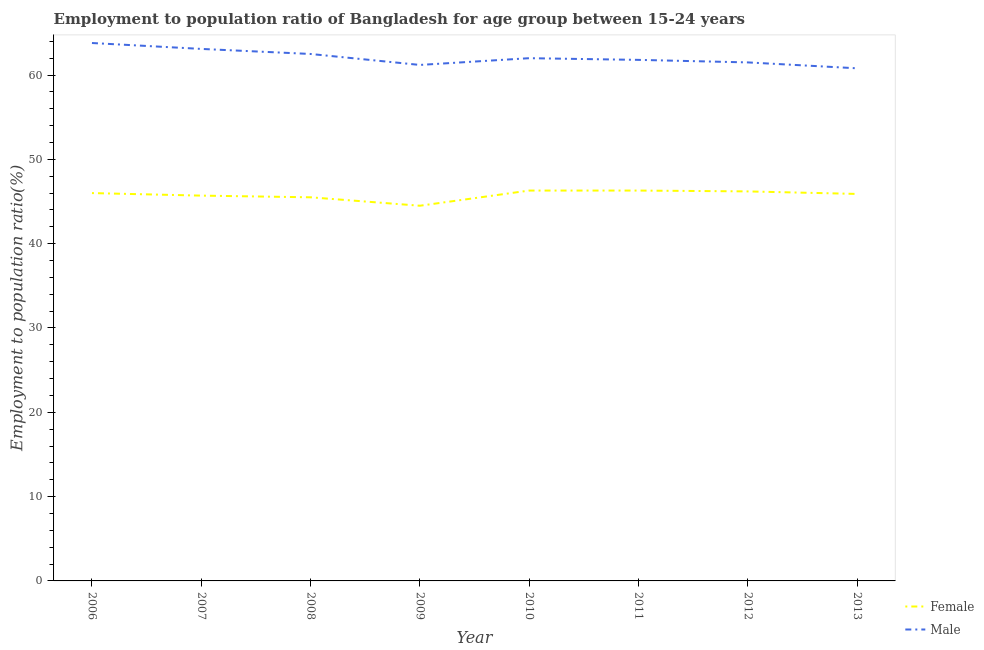How many different coloured lines are there?
Your answer should be very brief. 2. What is the employment to population ratio(male) in 2012?
Your response must be concise. 61.5. Across all years, what is the maximum employment to population ratio(female)?
Your response must be concise. 46.3. Across all years, what is the minimum employment to population ratio(female)?
Offer a terse response. 44.5. In which year was the employment to population ratio(male) minimum?
Offer a terse response. 2013. What is the total employment to population ratio(female) in the graph?
Your answer should be very brief. 366.4. What is the difference between the employment to population ratio(male) in 2008 and that in 2009?
Your answer should be very brief. 1.3. What is the average employment to population ratio(female) per year?
Offer a very short reply. 45.8. In the year 2011, what is the difference between the employment to population ratio(male) and employment to population ratio(female)?
Give a very brief answer. 15.5. In how many years, is the employment to population ratio(female) greater than 28 %?
Ensure brevity in your answer.  8. What is the ratio of the employment to population ratio(male) in 2009 to that in 2011?
Your response must be concise. 0.99. Is the difference between the employment to population ratio(male) in 2008 and 2013 greater than the difference between the employment to population ratio(female) in 2008 and 2013?
Your answer should be compact. Yes. What is the difference between the highest and the second highest employment to population ratio(male)?
Offer a very short reply. 0.7. Is the sum of the employment to population ratio(female) in 2009 and 2010 greater than the maximum employment to population ratio(male) across all years?
Your response must be concise. Yes. Does the employment to population ratio(male) monotonically increase over the years?
Your answer should be compact. No. Is the employment to population ratio(female) strictly less than the employment to population ratio(male) over the years?
Your response must be concise. Yes. How many years are there in the graph?
Your answer should be compact. 8. Are the values on the major ticks of Y-axis written in scientific E-notation?
Your response must be concise. No. Where does the legend appear in the graph?
Provide a short and direct response. Bottom right. How are the legend labels stacked?
Your answer should be very brief. Vertical. What is the title of the graph?
Provide a succinct answer. Employment to population ratio of Bangladesh for age group between 15-24 years. What is the label or title of the Y-axis?
Offer a very short reply. Employment to population ratio(%). What is the Employment to population ratio(%) in Female in 2006?
Provide a short and direct response. 46. What is the Employment to population ratio(%) of Male in 2006?
Keep it short and to the point. 63.8. What is the Employment to population ratio(%) of Female in 2007?
Make the answer very short. 45.7. What is the Employment to population ratio(%) of Male in 2007?
Your response must be concise. 63.1. What is the Employment to population ratio(%) in Female in 2008?
Your response must be concise. 45.5. What is the Employment to population ratio(%) in Male in 2008?
Offer a very short reply. 62.5. What is the Employment to population ratio(%) of Female in 2009?
Ensure brevity in your answer.  44.5. What is the Employment to population ratio(%) in Male in 2009?
Provide a short and direct response. 61.2. What is the Employment to population ratio(%) in Female in 2010?
Offer a terse response. 46.3. What is the Employment to population ratio(%) in Female in 2011?
Your answer should be compact. 46.3. What is the Employment to population ratio(%) in Male in 2011?
Provide a succinct answer. 61.8. What is the Employment to population ratio(%) in Female in 2012?
Provide a succinct answer. 46.2. What is the Employment to population ratio(%) in Male in 2012?
Make the answer very short. 61.5. What is the Employment to population ratio(%) of Female in 2013?
Provide a short and direct response. 45.9. What is the Employment to population ratio(%) of Male in 2013?
Make the answer very short. 60.8. Across all years, what is the maximum Employment to population ratio(%) in Female?
Provide a succinct answer. 46.3. Across all years, what is the maximum Employment to population ratio(%) of Male?
Provide a succinct answer. 63.8. Across all years, what is the minimum Employment to population ratio(%) of Female?
Offer a terse response. 44.5. Across all years, what is the minimum Employment to population ratio(%) in Male?
Keep it short and to the point. 60.8. What is the total Employment to population ratio(%) of Female in the graph?
Give a very brief answer. 366.4. What is the total Employment to population ratio(%) of Male in the graph?
Your response must be concise. 496.7. What is the difference between the Employment to population ratio(%) of Female in 2006 and that in 2007?
Give a very brief answer. 0.3. What is the difference between the Employment to population ratio(%) of Male in 2006 and that in 2008?
Your response must be concise. 1.3. What is the difference between the Employment to population ratio(%) of Female in 2006 and that in 2009?
Your answer should be compact. 1.5. What is the difference between the Employment to population ratio(%) of Male in 2006 and that in 2009?
Ensure brevity in your answer.  2.6. What is the difference between the Employment to population ratio(%) of Male in 2006 and that in 2010?
Ensure brevity in your answer.  1.8. What is the difference between the Employment to population ratio(%) of Female in 2007 and that in 2008?
Offer a terse response. 0.2. What is the difference between the Employment to population ratio(%) of Female in 2007 and that in 2010?
Your answer should be compact. -0.6. What is the difference between the Employment to population ratio(%) of Female in 2007 and that in 2011?
Provide a succinct answer. -0.6. What is the difference between the Employment to population ratio(%) in Male in 2007 and that in 2011?
Your answer should be compact. 1.3. What is the difference between the Employment to population ratio(%) of Female in 2008 and that in 2010?
Your answer should be very brief. -0.8. What is the difference between the Employment to population ratio(%) in Female in 2008 and that in 2012?
Your answer should be compact. -0.7. What is the difference between the Employment to population ratio(%) in Male in 2008 and that in 2012?
Ensure brevity in your answer.  1. What is the difference between the Employment to population ratio(%) of Male in 2008 and that in 2013?
Give a very brief answer. 1.7. What is the difference between the Employment to population ratio(%) in Male in 2009 and that in 2010?
Keep it short and to the point. -0.8. What is the difference between the Employment to population ratio(%) in Female in 2009 and that in 2011?
Keep it short and to the point. -1.8. What is the difference between the Employment to population ratio(%) of Male in 2009 and that in 2011?
Provide a succinct answer. -0.6. What is the difference between the Employment to population ratio(%) in Male in 2009 and that in 2012?
Keep it short and to the point. -0.3. What is the difference between the Employment to population ratio(%) of Male in 2009 and that in 2013?
Ensure brevity in your answer.  0.4. What is the difference between the Employment to population ratio(%) of Male in 2010 and that in 2012?
Provide a short and direct response. 0.5. What is the difference between the Employment to population ratio(%) of Female in 2010 and that in 2013?
Ensure brevity in your answer.  0.4. What is the difference between the Employment to population ratio(%) in Male in 2010 and that in 2013?
Offer a terse response. 1.2. What is the difference between the Employment to population ratio(%) in Female in 2011 and that in 2012?
Your answer should be compact. 0.1. What is the difference between the Employment to population ratio(%) of Male in 2011 and that in 2013?
Your answer should be very brief. 1. What is the difference between the Employment to population ratio(%) of Female in 2012 and that in 2013?
Provide a short and direct response. 0.3. What is the difference between the Employment to population ratio(%) of Female in 2006 and the Employment to population ratio(%) of Male in 2007?
Ensure brevity in your answer.  -17.1. What is the difference between the Employment to population ratio(%) of Female in 2006 and the Employment to population ratio(%) of Male in 2008?
Your answer should be compact. -16.5. What is the difference between the Employment to population ratio(%) in Female in 2006 and the Employment to population ratio(%) in Male in 2009?
Your response must be concise. -15.2. What is the difference between the Employment to population ratio(%) in Female in 2006 and the Employment to population ratio(%) in Male in 2010?
Provide a succinct answer. -16. What is the difference between the Employment to population ratio(%) of Female in 2006 and the Employment to population ratio(%) of Male in 2011?
Make the answer very short. -15.8. What is the difference between the Employment to population ratio(%) of Female in 2006 and the Employment to population ratio(%) of Male in 2012?
Offer a very short reply. -15.5. What is the difference between the Employment to population ratio(%) in Female in 2006 and the Employment to population ratio(%) in Male in 2013?
Offer a terse response. -14.8. What is the difference between the Employment to population ratio(%) of Female in 2007 and the Employment to population ratio(%) of Male in 2008?
Ensure brevity in your answer.  -16.8. What is the difference between the Employment to population ratio(%) in Female in 2007 and the Employment to population ratio(%) in Male in 2009?
Give a very brief answer. -15.5. What is the difference between the Employment to population ratio(%) of Female in 2007 and the Employment to population ratio(%) of Male in 2010?
Offer a terse response. -16.3. What is the difference between the Employment to population ratio(%) in Female in 2007 and the Employment to population ratio(%) in Male in 2011?
Your answer should be compact. -16.1. What is the difference between the Employment to population ratio(%) of Female in 2007 and the Employment to population ratio(%) of Male in 2012?
Offer a terse response. -15.8. What is the difference between the Employment to population ratio(%) in Female in 2007 and the Employment to population ratio(%) in Male in 2013?
Your response must be concise. -15.1. What is the difference between the Employment to population ratio(%) of Female in 2008 and the Employment to population ratio(%) of Male in 2009?
Your answer should be very brief. -15.7. What is the difference between the Employment to population ratio(%) in Female in 2008 and the Employment to population ratio(%) in Male in 2010?
Your answer should be very brief. -16.5. What is the difference between the Employment to population ratio(%) of Female in 2008 and the Employment to population ratio(%) of Male in 2011?
Make the answer very short. -16.3. What is the difference between the Employment to population ratio(%) of Female in 2008 and the Employment to population ratio(%) of Male in 2012?
Keep it short and to the point. -16. What is the difference between the Employment to population ratio(%) in Female in 2008 and the Employment to population ratio(%) in Male in 2013?
Your answer should be compact. -15.3. What is the difference between the Employment to population ratio(%) of Female in 2009 and the Employment to population ratio(%) of Male in 2010?
Your answer should be compact. -17.5. What is the difference between the Employment to population ratio(%) in Female in 2009 and the Employment to population ratio(%) in Male in 2011?
Ensure brevity in your answer.  -17.3. What is the difference between the Employment to population ratio(%) in Female in 2009 and the Employment to population ratio(%) in Male in 2013?
Ensure brevity in your answer.  -16.3. What is the difference between the Employment to population ratio(%) of Female in 2010 and the Employment to population ratio(%) of Male in 2011?
Give a very brief answer. -15.5. What is the difference between the Employment to population ratio(%) of Female in 2010 and the Employment to population ratio(%) of Male in 2012?
Offer a terse response. -15.2. What is the difference between the Employment to population ratio(%) in Female in 2011 and the Employment to population ratio(%) in Male in 2012?
Keep it short and to the point. -15.2. What is the difference between the Employment to population ratio(%) of Female in 2012 and the Employment to population ratio(%) of Male in 2013?
Your answer should be very brief. -14.6. What is the average Employment to population ratio(%) of Female per year?
Offer a very short reply. 45.8. What is the average Employment to population ratio(%) of Male per year?
Offer a very short reply. 62.09. In the year 2006, what is the difference between the Employment to population ratio(%) in Female and Employment to population ratio(%) in Male?
Make the answer very short. -17.8. In the year 2007, what is the difference between the Employment to population ratio(%) in Female and Employment to population ratio(%) in Male?
Give a very brief answer. -17.4. In the year 2008, what is the difference between the Employment to population ratio(%) in Female and Employment to population ratio(%) in Male?
Offer a terse response. -17. In the year 2009, what is the difference between the Employment to population ratio(%) of Female and Employment to population ratio(%) of Male?
Keep it short and to the point. -16.7. In the year 2010, what is the difference between the Employment to population ratio(%) in Female and Employment to population ratio(%) in Male?
Offer a very short reply. -15.7. In the year 2011, what is the difference between the Employment to population ratio(%) of Female and Employment to population ratio(%) of Male?
Provide a succinct answer. -15.5. In the year 2012, what is the difference between the Employment to population ratio(%) in Female and Employment to population ratio(%) in Male?
Keep it short and to the point. -15.3. In the year 2013, what is the difference between the Employment to population ratio(%) of Female and Employment to population ratio(%) of Male?
Your response must be concise. -14.9. What is the ratio of the Employment to population ratio(%) of Female in 2006 to that in 2007?
Your answer should be very brief. 1.01. What is the ratio of the Employment to population ratio(%) of Male in 2006 to that in 2007?
Your answer should be very brief. 1.01. What is the ratio of the Employment to population ratio(%) in Male in 2006 to that in 2008?
Provide a short and direct response. 1.02. What is the ratio of the Employment to population ratio(%) in Female in 2006 to that in 2009?
Ensure brevity in your answer.  1.03. What is the ratio of the Employment to population ratio(%) in Male in 2006 to that in 2009?
Give a very brief answer. 1.04. What is the ratio of the Employment to population ratio(%) in Female in 2006 to that in 2011?
Your response must be concise. 0.99. What is the ratio of the Employment to population ratio(%) of Male in 2006 to that in 2011?
Your answer should be very brief. 1.03. What is the ratio of the Employment to population ratio(%) in Male in 2006 to that in 2012?
Your answer should be compact. 1.04. What is the ratio of the Employment to population ratio(%) in Male in 2006 to that in 2013?
Your answer should be compact. 1.05. What is the ratio of the Employment to population ratio(%) of Male in 2007 to that in 2008?
Your answer should be compact. 1.01. What is the ratio of the Employment to population ratio(%) of Male in 2007 to that in 2009?
Keep it short and to the point. 1.03. What is the ratio of the Employment to population ratio(%) in Male in 2007 to that in 2010?
Make the answer very short. 1.02. What is the ratio of the Employment to population ratio(%) in Female in 2007 to that in 2011?
Offer a very short reply. 0.99. What is the ratio of the Employment to population ratio(%) in Female in 2007 to that in 2012?
Your answer should be compact. 0.99. What is the ratio of the Employment to population ratio(%) in Male in 2007 to that in 2013?
Your answer should be compact. 1.04. What is the ratio of the Employment to population ratio(%) in Female in 2008 to that in 2009?
Provide a succinct answer. 1.02. What is the ratio of the Employment to population ratio(%) in Male in 2008 to that in 2009?
Make the answer very short. 1.02. What is the ratio of the Employment to population ratio(%) of Female in 2008 to that in 2010?
Make the answer very short. 0.98. What is the ratio of the Employment to population ratio(%) in Male in 2008 to that in 2010?
Make the answer very short. 1.01. What is the ratio of the Employment to population ratio(%) in Female in 2008 to that in 2011?
Ensure brevity in your answer.  0.98. What is the ratio of the Employment to population ratio(%) in Male in 2008 to that in 2011?
Your answer should be compact. 1.01. What is the ratio of the Employment to population ratio(%) in Female in 2008 to that in 2012?
Keep it short and to the point. 0.98. What is the ratio of the Employment to population ratio(%) in Male in 2008 to that in 2012?
Keep it short and to the point. 1.02. What is the ratio of the Employment to population ratio(%) of Male in 2008 to that in 2013?
Offer a very short reply. 1.03. What is the ratio of the Employment to population ratio(%) of Female in 2009 to that in 2010?
Your response must be concise. 0.96. What is the ratio of the Employment to population ratio(%) of Male in 2009 to that in 2010?
Your answer should be very brief. 0.99. What is the ratio of the Employment to population ratio(%) in Female in 2009 to that in 2011?
Keep it short and to the point. 0.96. What is the ratio of the Employment to population ratio(%) of Male in 2009 to that in 2011?
Provide a short and direct response. 0.99. What is the ratio of the Employment to population ratio(%) of Female in 2009 to that in 2012?
Your answer should be very brief. 0.96. What is the ratio of the Employment to population ratio(%) in Female in 2009 to that in 2013?
Your answer should be compact. 0.97. What is the ratio of the Employment to population ratio(%) of Male in 2009 to that in 2013?
Provide a short and direct response. 1.01. What is the ratio of the Employment to population ratio(%) of Female in 2010 to that in 2012?
Your response must be concise. 1. What is the ratio of the Employment to population ratio(%) in Male in 2010 to that in 2012?
Provide a short and direct response. 1.01. What is the ratio of the Employment to population ratio(%) in Female in 2010 to that in 2013?
Offer a very short reply. 1.01. What is the ratio of the Employment to population ratio(%) of Male in 2010 to that in 2013?
Give a very brief answer. 1.02. What is the ratio of the Employment to population ratio(%) of Female in 2011 to that in 2012?
Keep it short and to the point. 1. What is the ratio of the Employment to population ratio(%) in Male in 2011 to that in 2012?
Offer a terse response. 1. What is the ratio of the Employment to population ratio(%) of Female in 2011 to that in 2013?
Ensure brevity in your answer.  1.01. What is the ratio of the Employment to population ratio(%) of Male in 2011 to that in 2013?
Make the answer very short. 1.02. What is the ratio of the Employment to population ratio(%) of Female in 2012 to that in 2013?
Your response must be concise. 1.01. What is the ratio of the Employment to population ratio(%) in Male in 2012 to that in 2013?
Keep it short and to the point. 1.01. What is the difference between the highest and the lowest Employment to population ratio(%) in Male?
Make the answer very short. 3. 